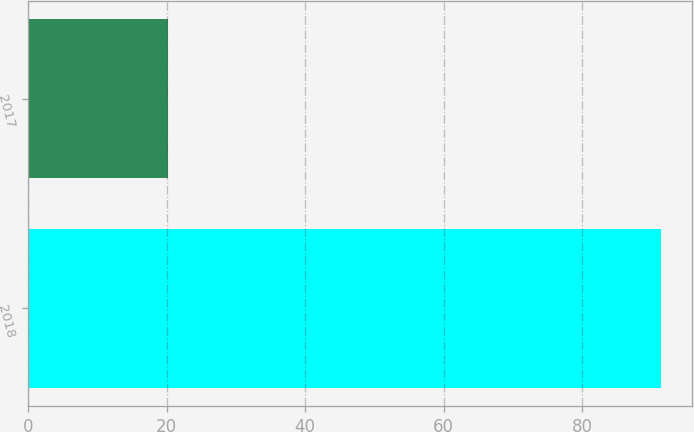<chart> <loc_0><loc_0><loc_500><loc_500><bar_chart><fcel>2018<fcel>2017<nl><fcel>91.3<fcel>20.2<nl></chart> 